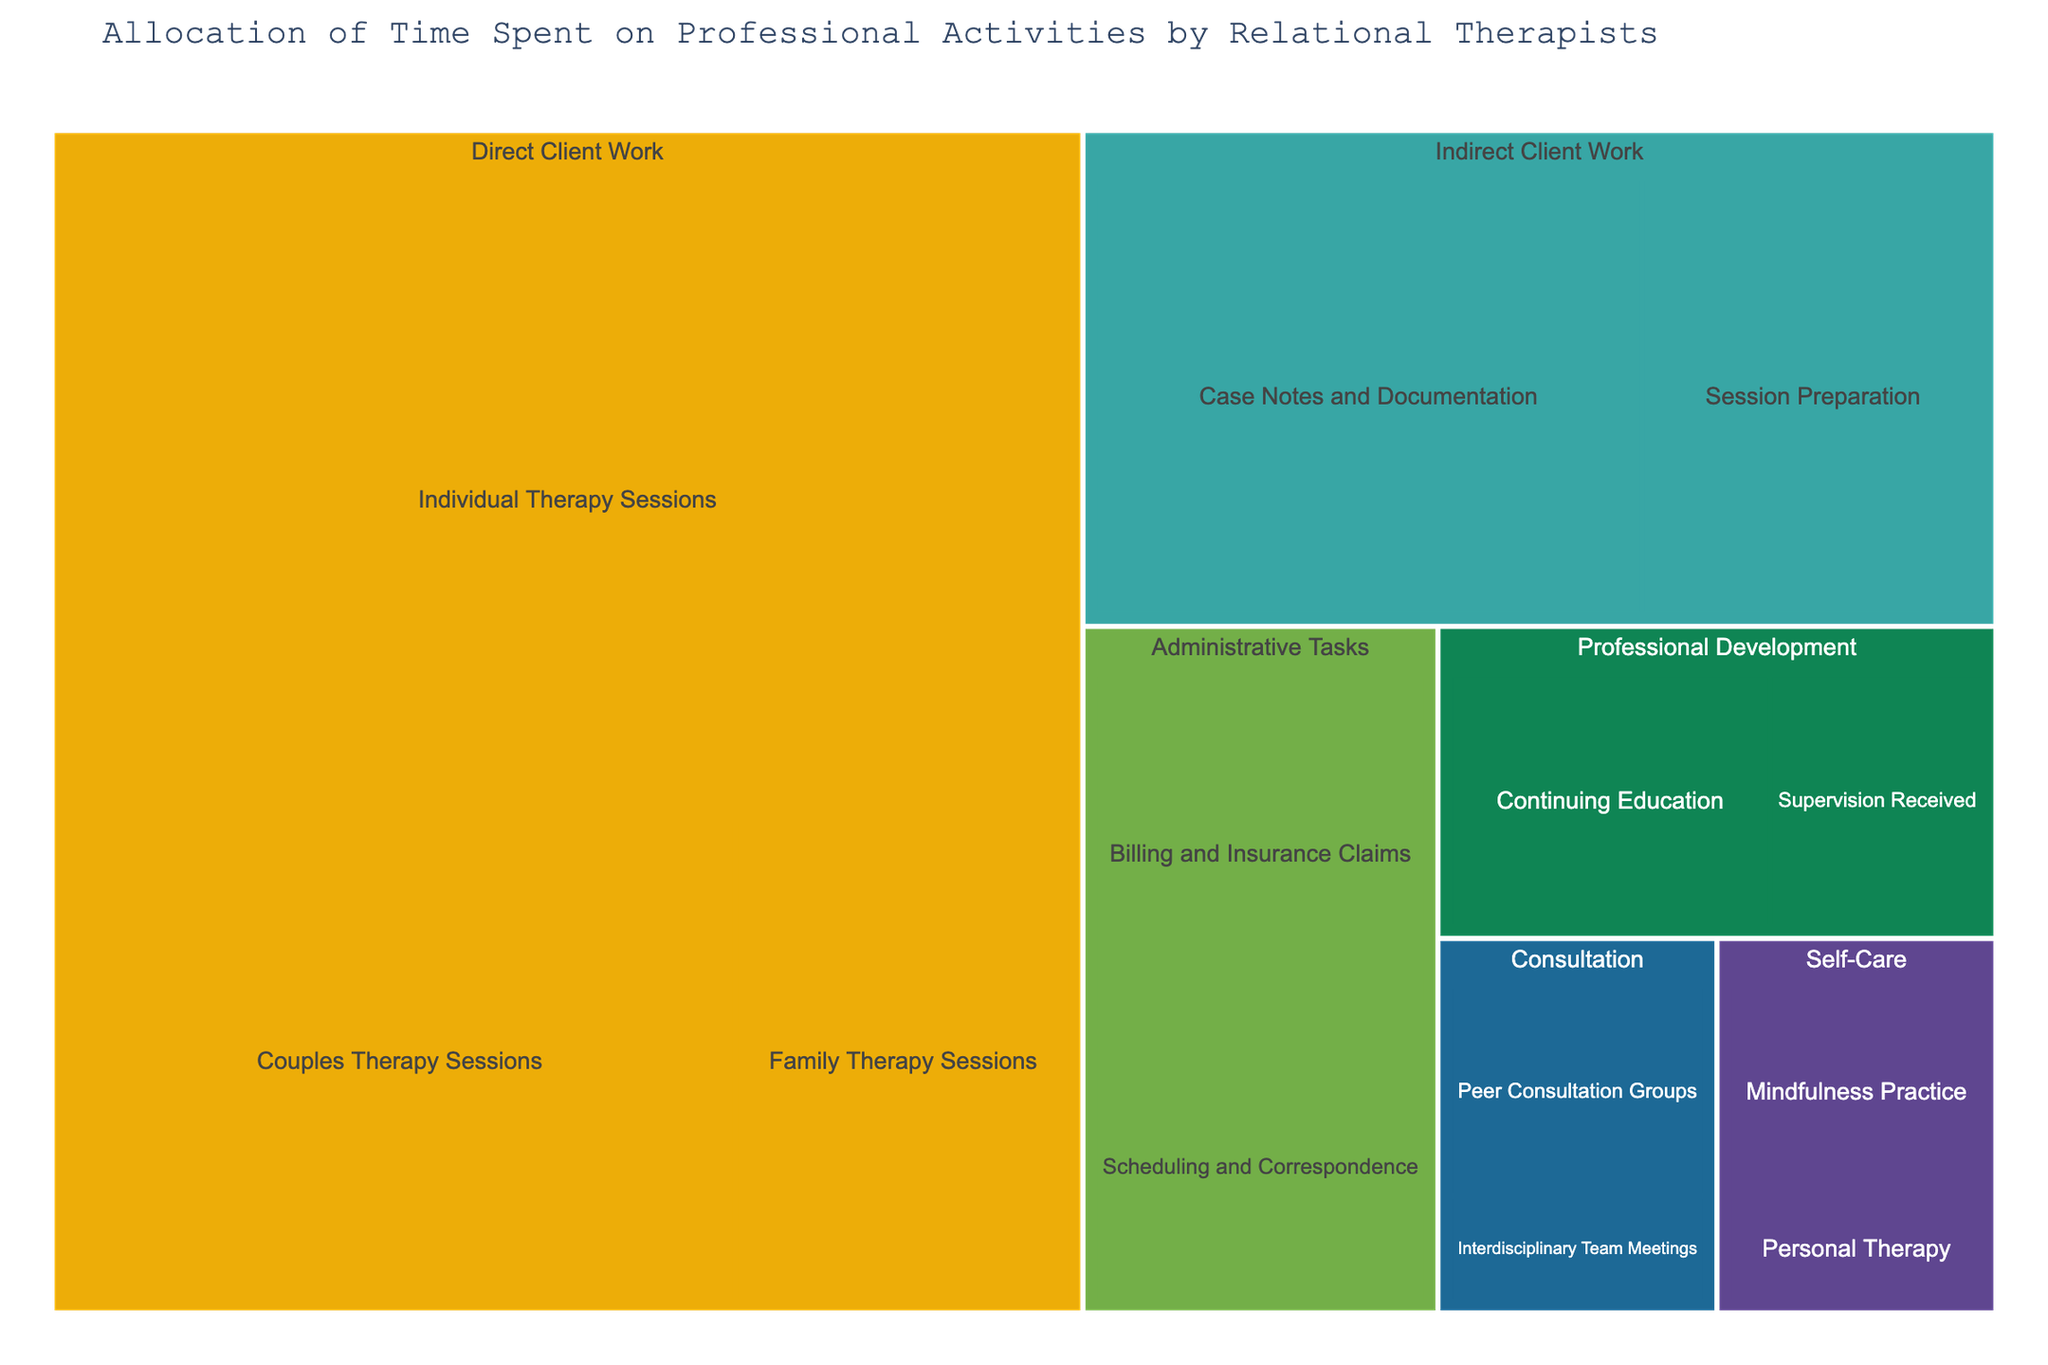What professional activity category has the most hours allocated? Look for the category with the largest area in the treemap, which represents the largest total number of hours. The 'Direct Client Work' category has the most hours allocated.
Answer: Direct Client Work How many hours in total are spent on therapy sessions? Add up the hours for individual, couples, and family therapy sessions: 20 (individual) + 10 (couples) + 5 (family) = 35.
Answer: 35 Which activity within the 'Administrative Tasks' category has more hours, 'Billing and Insurance Claims' or 'Scheduling and Correspondence'? Compare the hours for each activity within this category. 'Billing and Insurance Claims' has 4 hours and 'Scheduling and Correspondence' has 3 hours.
Answer: Billing and Insurance Claims How many hours are dedicated to 'Professional Development'? Sum the hours for 'Supervision Received' and 'Continuing Education': 2 (supervision) + 3 (education) = 5.
Answer: 5 What is the total average time spent on activities in the 'Self-Care' and 'Consultation' categories? Calculate the total hours and divide by the number of activities. 'Self-Care': 1 (personal therapy) + 2 (mindfulness) = 3. 'Consultation': 2 (peer consultation) + 1 (team meetings) = 3. The total hours are 3 (self-care) + 3 (consultation) = 6. There are 4 activities in total across these categories, so the average is 6/4 = 1.5.
Answer: 1.5 Which activity has the least amount of hours allocated? Identify the smallest segment in the treemap. 'Interdisciplinary Team Meetings' within the 'Consultation' category has the least amount with 1 hour.
Answer: Interdisciplinary Team Meetings Compare the hours spent on 'Direct Client Work' and 'Indirect Client Work'. Which one has more hours, and by how much? Calculate the total hours for each category. 'Direct Client Work' has 20 (individual) + 10 (couples) + 5 (family) = 35. 'Indirect Client Work' has 5 (preparation) + 8 (documentation) = 13. The difference is 35 - 13 = 22.
Answer: Direct Client Work by 22 hours What is the sum of hours spent on 'Session Preparation' and 'Case Notes and Documentation'? Add the hours for these two activities. 'Session Preparation' has 5 hours and 'Case Notes and Documentation' has 8 hours. So, 5 + 8 = 13.
Answer: 13 What is the proportion of time spent on 'Individual Therapy Sessions' compared to total 'Direct Client Work' hours? Calculate the proportion by dividing the hours of 'Individual Therapy Sessions' by the total 'Direct Client Work' hours. 'Individual Therapy Sessions' has 20 hours. Total 'Direct Client Work' hours is 35. So, 20/35 ≈ 0.571 or 57.1%.
Answer: 57.1% 